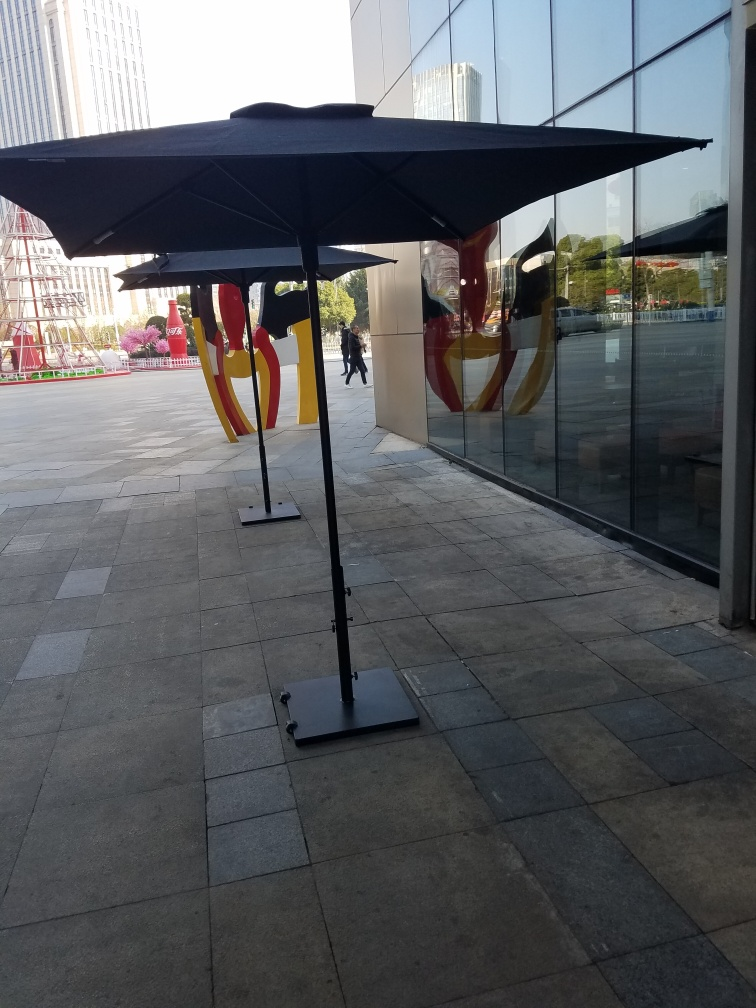What time of day does this image suggest, and what clues lead to that conclusion? The image suggests it is taken during the early or late hours of the day when the sun is at a lower angle, creating long and pronounced shadows. This observation is supported by the length and direction of the shadows cast on the pavement, along with the warm lighting that typically indicates sunrise or sunset hours. 